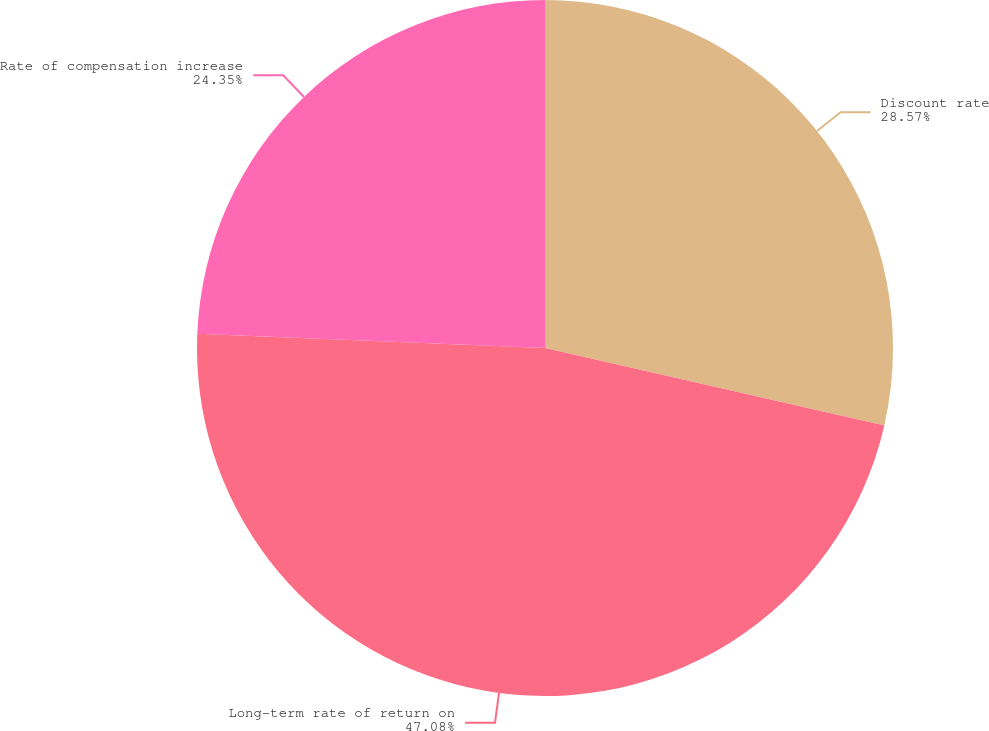Convert chart to OTSL. <chart><loc_0><loc_0><loc_500><loc_500><pie_chart><fcel>Discount rate<fcel>Long-term rate of return on<fcel>Rate of compensation increase<nl><fcel>28.57%<fcel>47.08%<fcel>24.35%<nl></chart> 